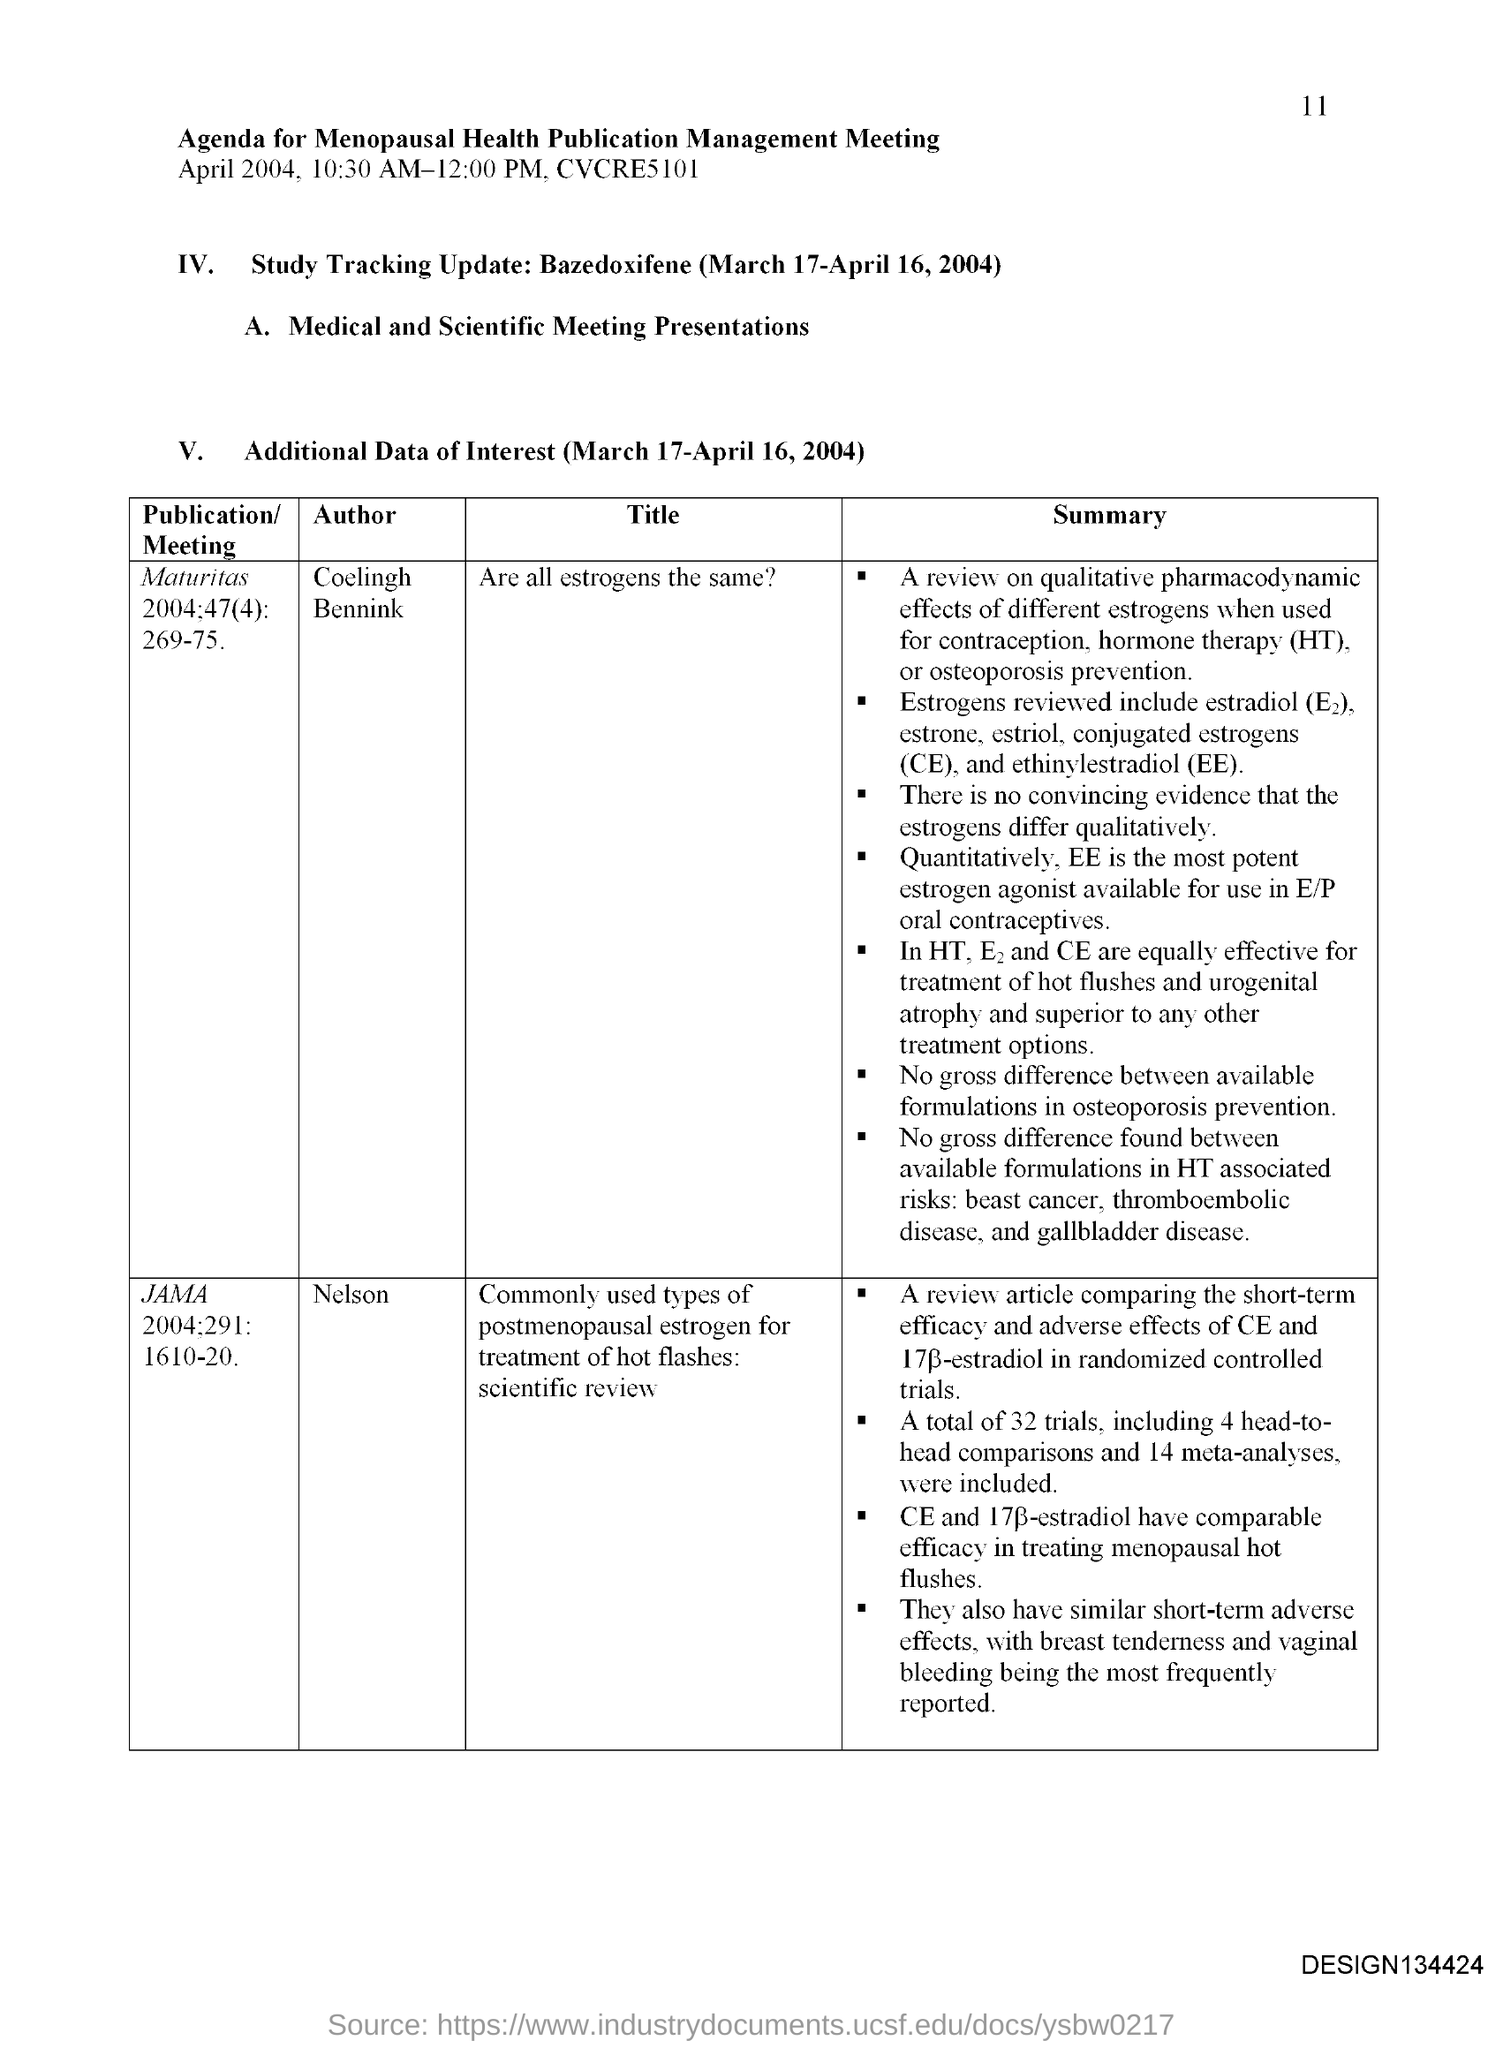Outline some significant characteristics in this image. The abbreviation for conjugated estrogens is CE. Hormone therapy," which is commonly referred to as "HT," is a medical treatment that involves the use of hormones to alleviate symptoms caused by hormone imbalances or deficiencies. The full form of EE is Ethinylestradiol. 